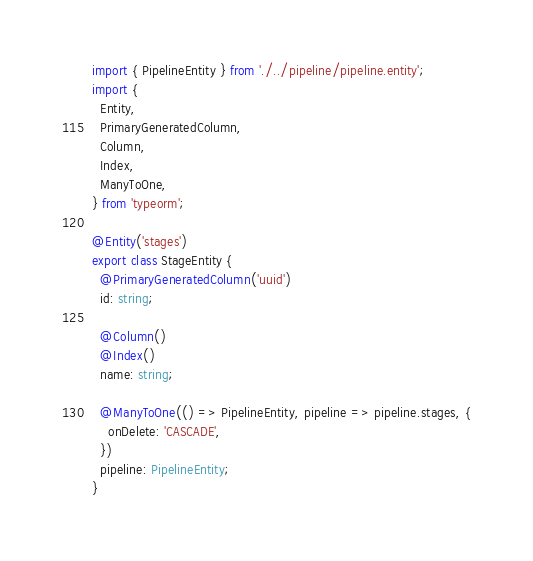<code> <loc_0><loc_0><loc_500><loc_500><_TypeScript_>import { PipelineEntity } from './../pipeline/pipeline.entity';
import {
  Entity,
  PrimaryGeneratedColumn,
  Column,
  Index,
  ManyToOne,
} from 'typeorm';

@Entity('stages')
export class StageEntity {
  @PrimaryGeneratedColumn('uuid')
  id: string;

  @Column()
  @Index()
  name: string;

  @ManyToOne(() => PipelineEntity, pipeline => pipeline.stages, {
    onDelete: 'CASCADE',
  })
  pipeline: PipelineEntity;
}
</code> 